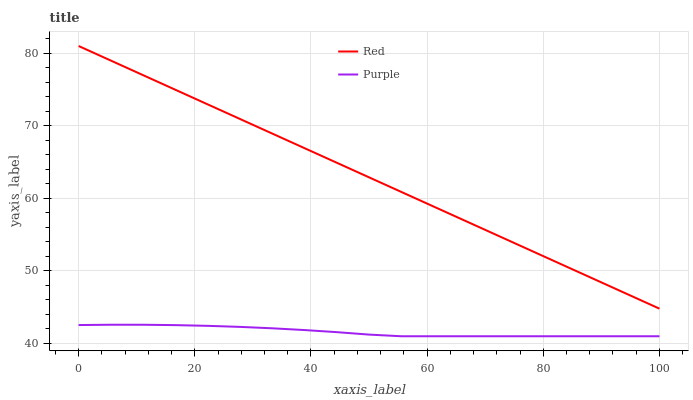Does Red have the minimum area under the curve?
Answer yes or no. No. Is Red the roughest?
Answer yes or no. No. Does Red have the lowest value?
Answer yes or no. No. Is Purple less than Red?
Answer yes or no. Yes. Is Red greater than Purple?
Answer yes or no. Yes. Does Purple intersect Red?
Answer yes or no. No. 